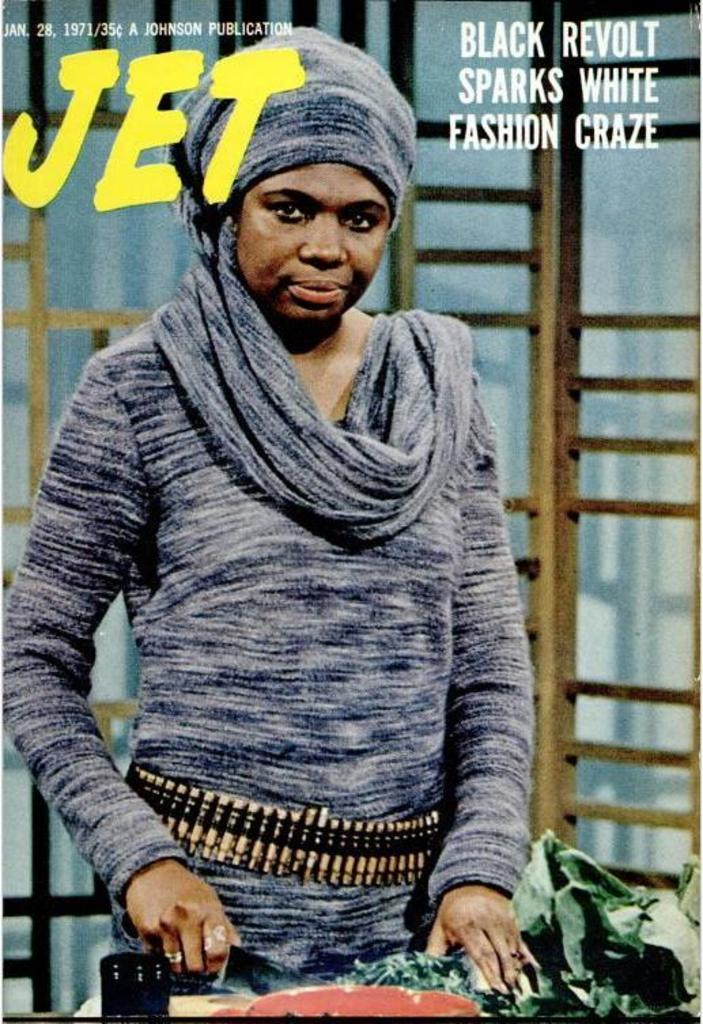What is featured on the poster in the image? There is a poster in the image, and it features a person. What else can be seen on the poster besides the person? There is text present on the poster. What type of country is depicted on the poster? There is no country depicted on the poster; it features a person and text. What is the cause of the cart in the image? There is no cart present in the image, so it is not possible to determine the cause of a cart. 